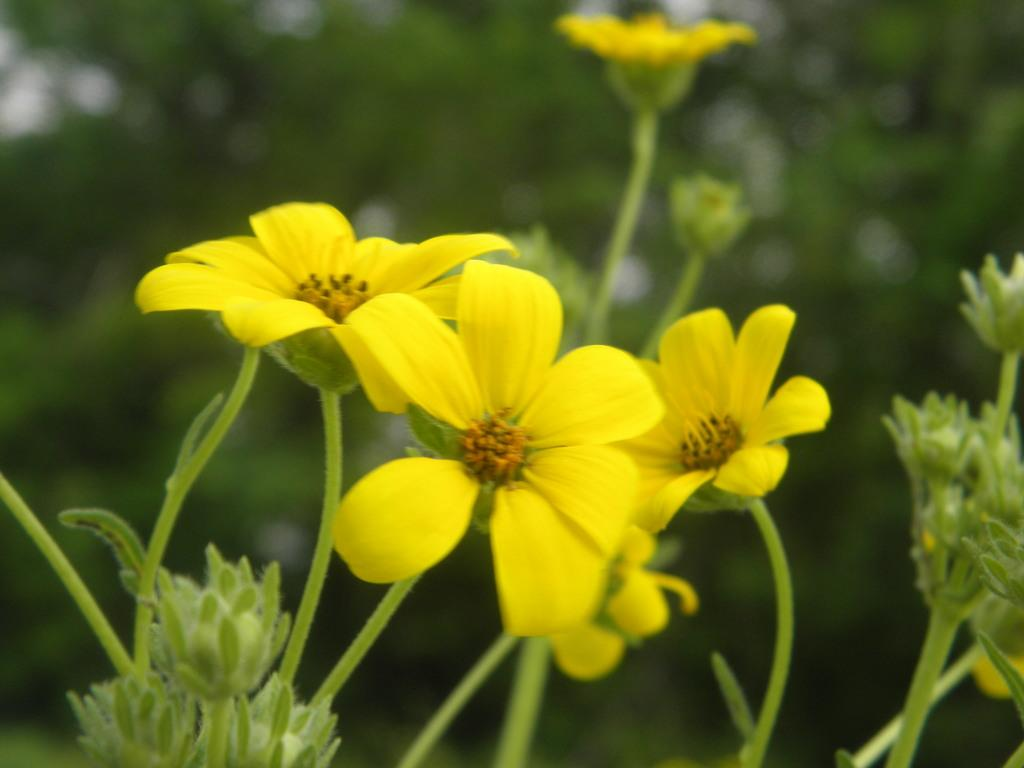What type of flowers can be seen in the image? There are yellow flowers in the image. Can you describe the quality of the image's background? The image is blurry in the background. Is there a cat sitting on the art in the background of the image? There is no cat or art present in the image; it only features yellow flowers with a blurry background. 